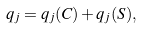Convert formula to latex. <formula><loc_0><loc_0><loc_500><loc_500>q _ { j } = q _ { j } ( C ) + q _ { j } ( S ) ,</formula> 